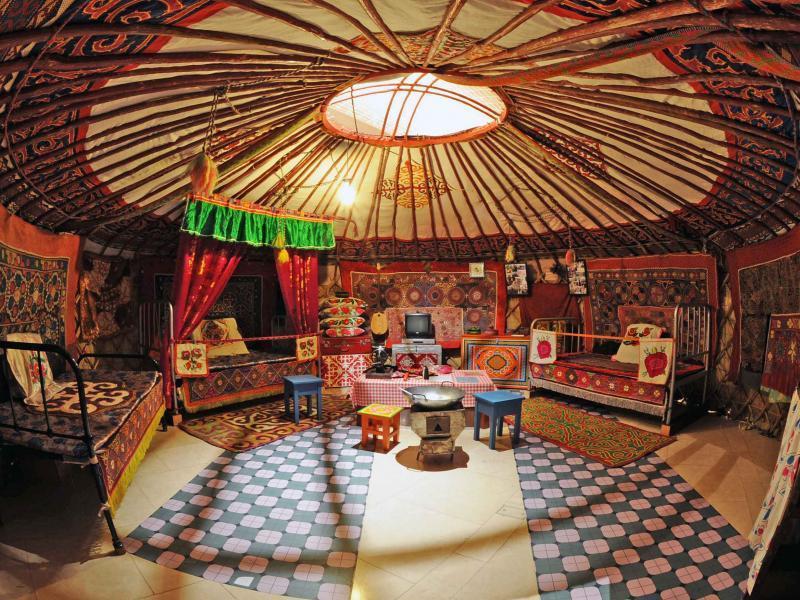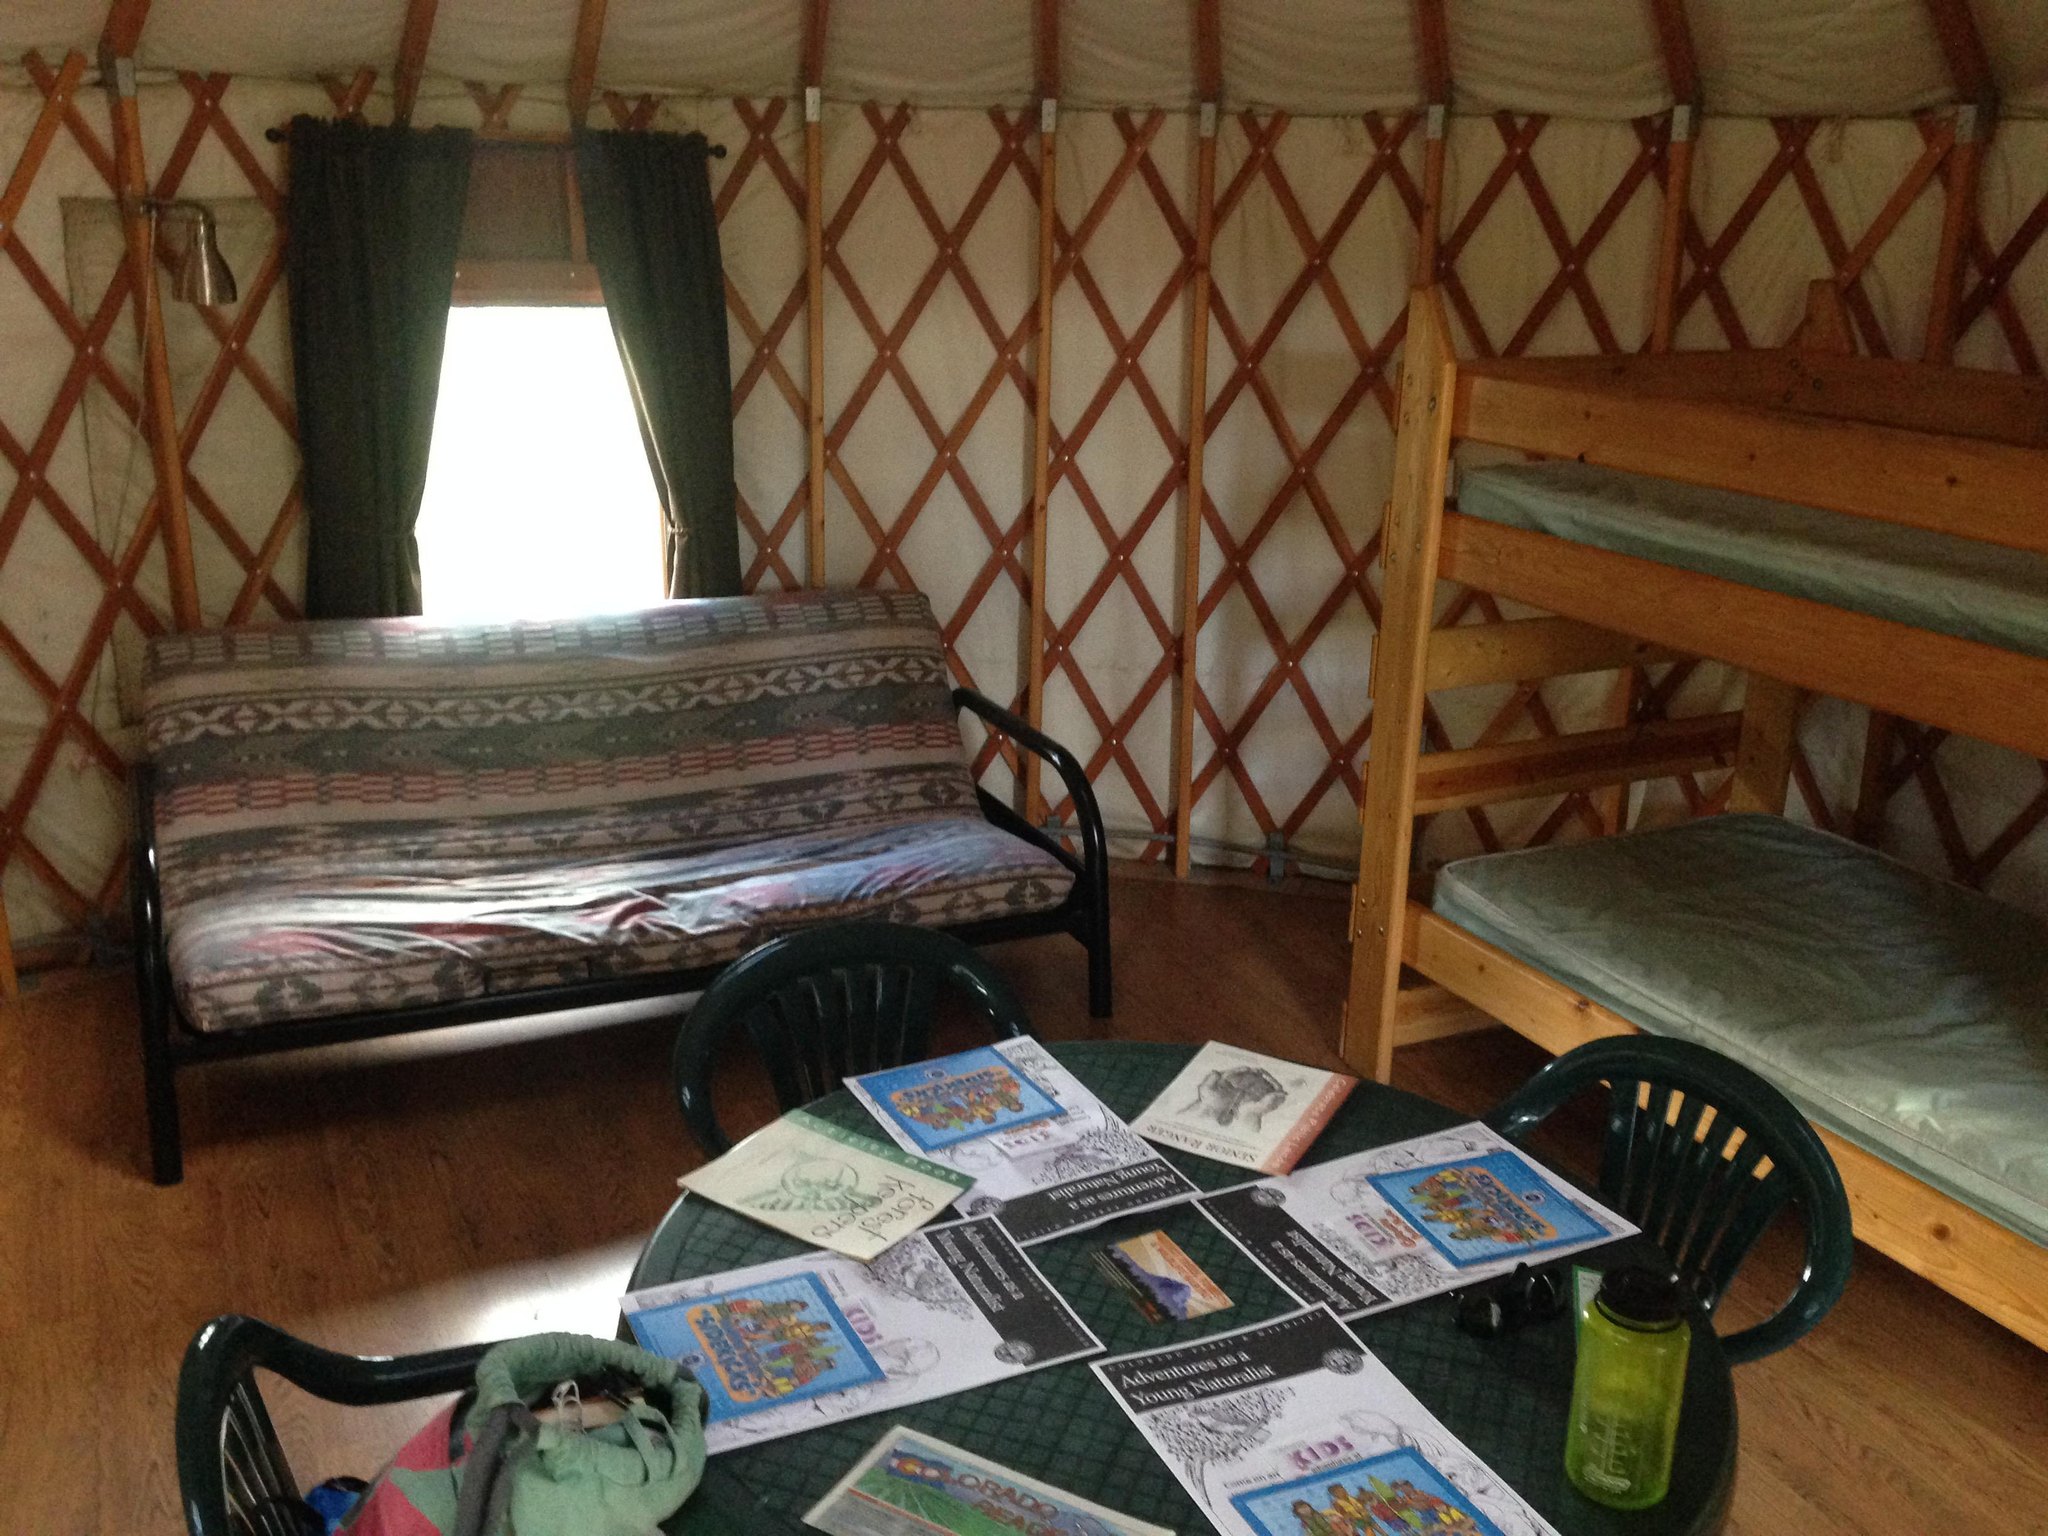The first image is the image on the left, the second image is the image on the right. For the images shown, is this caption "Both images are interior shots of round houses." true? Answer yes or no. Yes. The first image is the image on the left, the second image is the image on the right. Assess this claim about the two images: "At least one image shows a building in a snowy setting.". Correct or not? Answer yes or no. No. 